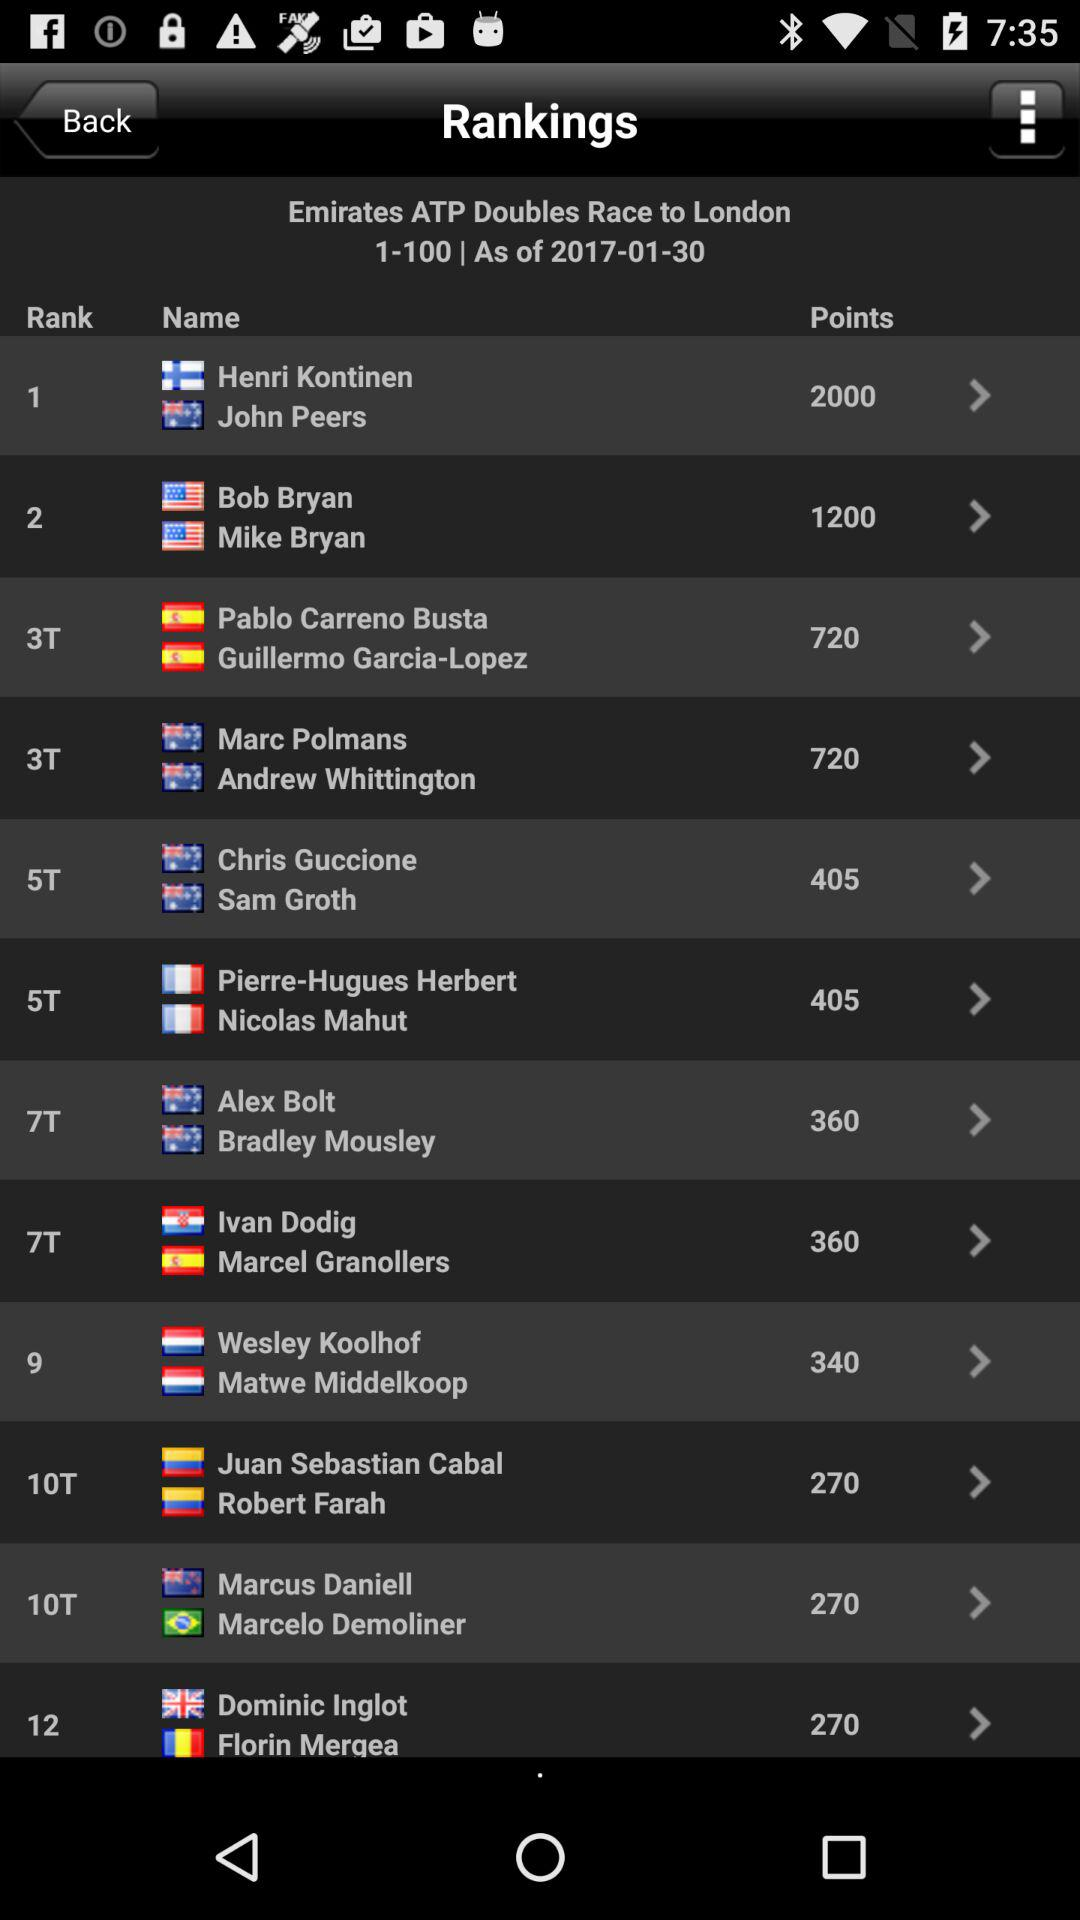What is the total count of pages? The total count of pages is 100. 